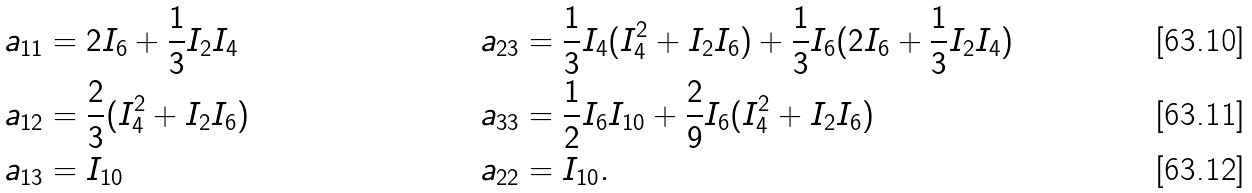Convert formula to latex. <formula><loc_0><loc_0><loc_500><loc_500>a _ { 1 1 } & = 2 I _ { 6 } + \frac { 1 } { 3 } I _ { 2 } I _ { 4 } & a _ { 2 3 } & = \frac { 1 } { 3 } I _ { 4 } ( I _ { 4 } ^ { 2 } + I _ { 2 } I _ { 6 } ) + \frac { 1 } { 3 } I _ { 6 } ( 2 I _ { 6 } + \frac { 1 } { 3 } I _ { 2 } I _ { 4 } ) \\ a _ { 1 2 } & = \frac { 2 } { 3 } ( I _ { 4 } ^ { 2 } + I _ { 2 } I _ { 6 } ) & a _ { 3 3 } & = \frac { 1 } { 2 } I _ { 6 } I _ { 1 0 } + \frac { 2 } { 9 } I _ { 6 } ( I _ { 4 } ^ { 2 } + I _ { 2 } I _ { 6 } ) \\ a _ { 1 3 } & = I _ { 1 0 } & a _ { 2 2 } & = I _ { 1 0 } .</formula> 